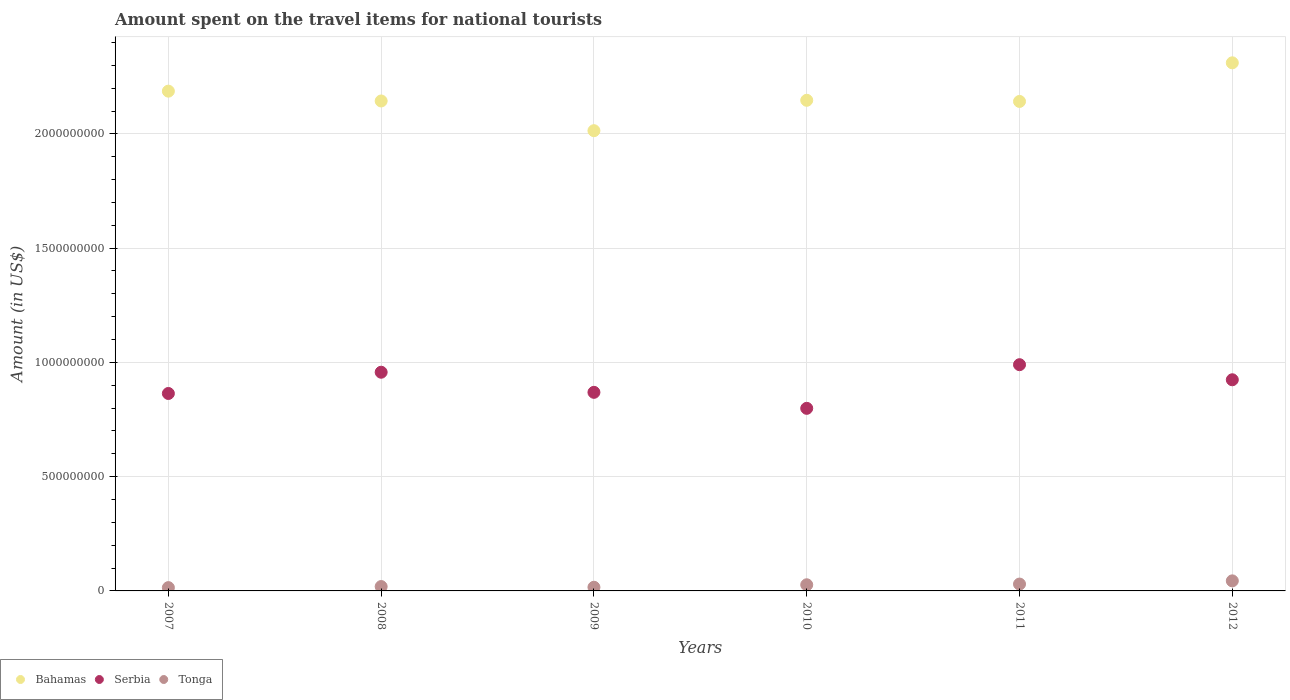How many different coloured dotlines are there?
Give a very brief answer. 3. What is the amount spent on the travel items for national tourists in Serbia in 2010?
Provide a short and direct response. 7.99e+08. Across all years, what is the maximum amount spent on the travel items for national tourists in Tonga?
Give a very brief answer. 4.40e+07. Across all years, what is the minimum amount spent on the travel items for national tourists in Tonga?
Make the answer very short. 1.44e+07. In which year was the amount spent on the travel items for national tourists in Serbia maximum?
Keep it short and to the point. 2011. What is the total amount spent on the travel items for national tourists in Tonga in the graph?
Make the answer very short. 1.50e+08. What is the difference between the amount spent on the travel items for national tourists in Serbia in 2009 and that in 2012?
Ensure brevity in your answer.  -5.50e+07. What is the difference between the amount spent on the travel items for national tourists in Serbia in 2008 and the amount spent on the travel items for national tourists in Bahamas in 2007?
Give a very brief answer. -1.23e+09. What is the average amount spent on the travel items for national tourists in Serbia per year?
Your answer should be very brief. 9.00e+08. In the year 2010, what is the difference between the amount spent on the travel items for national tourists in Serbia and amount spent on the travel items for national tourists in Tonga?
Provide a short and direct response. 7.72e+08. What is the ratio of the amount spent on the travel items for national tourists in Serbia in 2007 to that in 2012?
Your response must be concise. 0.94. Is the difference between the amount spent on the travel items for national tourists in Serbia in 2008 and 2010 greater than the difference between the amount spent on the travel items for national tourists in Tonga in 2008 and 2010?
Give a very brief answer. Yes. What is the difference between the highest and the second highest amount spent on the travel items for national tourists in Serbia?
Your answer should be very brief. 3.30e+07. What is the difference between the highest and the lowest amount spent on the travel items for national tourists in Bahamas?
Keep it short and to the point. 2.97e+08. In how many years, is the amount spent on the travel items for national tourists in Serbia greater than the average amount spent on the travel items for national tourists in Serbia taken over all years?
Provide a short and direct response. 3. Is it the case that in every year, the sum of the amount spent on the travel items for national tourists in Tonga and amount spent on the travel items for national tourists in Serbia  is greater than the amount spent on the travel items for national tourists in Bahamas?
Your answer should be very brief. No. Does the amount spent on the travel items for national tourists in Serbia monotonically increase over the years?
Give a very brief answer. No. How many dotlines are there?
Offer a very short reply. 3. How many years are there in the graph?
Keep it short and to the point. 6. Does the graph contain any zero values?
Ensure brevity in your answer.  No. How are the legend labels stacked?
Ensure brevity in your answer.  Horizontal. What is the title of the graph?
Keep it short and to the point. Amount spent on the travel items for national tourists. Does "Georgia" appear as one of the legend labels in the graph?
Your answer should be very brief. No. What is the Amount (in US$) in Bahamas in 2007?
Ensure brevity in your answer.  2.19e+09. What is the Amount (in US$) in Serbia in 2007?
Your answer should be compact. 8.64e+08. What is the Amount (in US$) of Tonga in 2007?
Keep it short and to the point. 1.44e+07. What is the Amount (in US$) of Bahamas in 2008?
Make the answer very short. 2.14e+09. What is the Amount (in US$) of Serbia in 2008?
Give a very brief answer. 9.57e+08. What is the Amount (in US$) in Tonga in 2008?
Provide a short and direct response. 1.91e+07. What is the Amount (in US$) in Bahamas in 2009?
Offer a terse response. 2.01e+09. What is the Amount (in US$) of Serbia in 2009?
Your answer should be very brief. 8.69e+08. What is the Amount (in US$) of Tonga in 2009?
Your answer should be very brief. 1.60e+07. What is the Amount (in US$) of Bahamas in 2010?
Keep it short and to the point. 2.15e+09. What is the Amount (in US$) in Serbia in 2010?
Keep it short and to the point. 7.99e+08. What is the Amount (in US$) in Tonga in 2010?
Your response must be concise. 2.69e+07. What is the Amount (in US$) in Bahamas in 2011?
Provide a succinct answer. 2.14e+09. What is the Amount (in US$) in Serbia in 2011?
Give a very brief answer. 9.90e+08. What is the Amount (in US$) of Tonga in 2011?
Make the answer very short. 3.00e+07. What is the Amount (in US$) of Bahamas in 2012?
Give a very brief answer. 2.31e+09. What is the Amount (in US$) in Serbia in 2012?
Make the answer very short. 9.24e+08. What is the Amount (in US$) in Tonga in 2012?
Provide a short and direct response. 4.40e+07. Across all years, what is the maximum Amount (in US$) of Bahamas?
Make the answer very short. 2.31e+09. Across all years, what is the maximum Amount (in US$) of Serbia?
Ensure brevity in your answer.  9.90e+08. Across all years, what is the maximum Amount (in US$) in Tonga?
Make the answer very short. 4.40e+07. Across all years, what is the minimum Amount (in US$) of Bahamas?
Your answer should be very brief. 2.01e+09. Across all years, what is the minimum Amount (in US$) of Serbia?
Provide a succinct answer. 7.99e+08. Across all years, what is the minimum Amount (in US$) of Tonga?
Your answer should be compact. 1.44e+07. What is the total Amount (in US$) in Bahamas in the graph?
Your answer should be very brief. 1.29e+1. What is the total Amount (in US$) in Serbia in the graph?
Ensure brevity in your answer.  5.40e+09. What is the total Amount (in US$) in Tonga in the graph?
Keep it short and to the point. 1.50e+08. What is the difference between the Amount (in US$) in Bahamas in 2007 and that in 2008?
Offer a very short reply. 4.30e+07. What is the difference between the Amount (in US$) of Serbia in 2007 and that in 2008?
Offer a very short reply. -9.30e+07. What is the difference between the Amount (in US$) of Tonga in 2007 and that in 2008?
Your response must be concise. -4.70e+06. What is the difference between the Amount (in US$) in Bahamas in 2007 and that in 2009?
Ensure brevity in your answer.  1.73e+08. What is the difference between the Amount (in US$) in Serbia in 2007 and that in 2009?
Offer a very short reply. -5.00e+06. What is the difference between the Amount (in US$) of Tonga in 2007 and that in 2009?
Ensure brevity in your answer.  -1.60e+06. What is the difference between the Amount (in US$) of Bahamas in 2007 and that in 2010?
Offer a terse response. 4.00e+07. What is the difference between the Amount (in US$) of Serbia in 2007 and that in 2010?
Offer a very short reply. 6.50e+07. What is the difference between the Amount (in US$) in Tonga in 2007 and that in 2010?
Your response must be concise. -1.25e+07. What is the difference between the Amount (in US$) in Bahamas in 2007 and that in 2011?
Make the answer very short. 4.50e+07. What is the difference between the Amount (in US$) of Serbia in 2007 and that in 2011?
Offer a very short reply. -1.26e+08. What is the difference between the Amount (in US$) in Tonga in 2007 and that in 2011?
Keep it short and to the point. -1.56e+07. What is the difference between the Amount (in US$) in Bahamas in 2007 and that in 2012?
Your response must be concise. -1.24e+08. What is the difference between the Amount (in US$) of Serbia in 2007 and that in 2012?
Ensure brevity in your answer.  -6.00e+07. What is the difference between the Amount (in US$) of Tonga in 2007 and that in 2012?
Keep it short and to the point. -2.96e+07. What is the difference between the Amount (in US$) in Bahamas in 2008 and that in 2009?
Your answer should be very brief. 1.30e+08. What is the difference between the Amount (in US$) in Serbia in 2008 and that in 2009?
Provide a short and direct response. 8.80e+07. What is the difference between the Amount (in US$) in Tonga in 2008 and that in 2009?
Provide a succinct answer. 3.10e+06. What is the difference between the Amount (in US$) of Serbia in 2008 and that in 2010?
Provide a succinct answer. 1.58e+08. What is the difference between the Amount (in US$) in Tonga in 2008 and that in 2010?
Your answer should be compact. -7.80e+06. What is the difference between the Amount (in US$) in Bahamas in 2008 and that in 2011?
Provide a succinct answer. 2.00e+06. What is the difference between the Amount (in US$) in Serbia in 2008 and that in 2011?
Provide a succinct answer. -3.30e+07. What is the difference between the Amount (in US$) in Tonga in 2008 and that in 2011?
Your response must be concise. -1.09e+07. What is the difference between the Amount (in US$) in Bahamas in 2008 and that in 2012?
Offer a very short reply. -1.67e+08. What is the difference between the Amount (in US$) in Serbia in 2008 and that in 2012?
Provide a short and direct response. 3.30e+07. What is the difference between the Amount (in US$) in Tonga in 2008 and that in 2012?
Provide a succinct answer. -2.49e+07. What is the difference between the Amount (in US$) of Bahamas in 2009 and that in 2010?
Provide a short and direct response. -1.33e+08. What is the difference between the Amount (in US$) in Serbia in 2009 and that in 2010?
Provide a short and direct response. 7.00e+07. What is the difference between the Amount (in US$) of Tonga in 2009 and that in 2010?
Your response must be concise. -1.09e+07. What is the difference between the Amount (in US$) in Bahamas in 2009 and that in 2011?
Your response must be concise. -1.28e+08. What is the difference between the Amount (in US$) of Serbia in 2009 and that in 2011?
Your response must be concise. -1.21e+08. What is the difference between the Amount (in US$) of Tonga in 2009 and that in 2011?
Give a very brief answer. -1.40e+07. What is the difference between the Amount (in US$) of Bahamas in 2009 and that in 2012?
Offer a terse response. -2.97e+08. What is the difference between the Amount (in US$) in Serbia in 2009 and that in 2012?
Ensure brevity in your answer.  -5.50e+07. What is the difference between the Amount (in US$) of Tonga in 2009 and that in 2012?
Give a very brief answer. -2.80e+07. What is the difference between the Amount (in US$) in Bahamas in 2010 and that in 2011?
Provide a short and direct response. 5.00e+06. What is the difference between the Amount (in US$) in Serbia in 2010 and that in 2011?
Provide a short and direct response. -1.91e+08. What is the difference between the Amount (in US$) in Tonga in 2010 and that in 2011?
Ensure brevity in your answer.  -3.10e+06. What is the difference between the Amount (in US$) in Bahamas in 2010 and that in 2012?
Provide a short and direct response. -1.64e+08. What is the difference between the Amount (in US$) in Serbia in 2010 and that in 2012?
Your answer should be very brief. -1.25e+08. What is the difference between the Amount (in US$) of Tonga in 2010 and that in 2012?
Offer a terse response. -1.71e+07. What is the difference between the Amount (in US$) in Bahamas in 2011 and that in 2012?
Provide a short and direct response. -1.69e+08. What is the difference between the Amount (in US$) in Serbia in 2011 and that in 2012?
Provide a succinct answer. 6.60e+07. What is the difference between the Amount (in US$) of Tonga in 2011 and that in 2012?
Provide a short and direct response. -1.40e+07. What is the difference between the Amount (in US$) of Bahamas in 2007 and the Amount (in US$) of Serbia in 2008?
Give a very brief answer. 1.23e+09. What is the difference between the Amount (in US$) in Bahamas in 2007 and the Amount (in US$) in Tonga in 2008?
Ensure brevity in your answer.  2.17e+09. What is the difference between the Amount (in US$) in Serbia in 2007 and the Amount (in US$) in Tonga in 2008?
Ensure brevity in your answer.  8.45e+08. What is the difference between the Amount (in US$) in Bahamas in 2007 and the Amount (in US$) in Serbia in 2009?
Your answer should be compact. 1.32e+09. What is the difference between the Amount (in US$) in Bahamas in 2007 and the Amount (in US$) in Tonga in 2009?
Keep it short and to the point. 2.17e+09. What is the difference between the Amount (in US$) of Serbia in 2007 and the Amount (in US$) of Tonga in 2009?
Ensure brevity in your answer.  8.48e+08. What is the difference between the Amount (in US$) of Bahamas in 2007 and the Amount (in US$) of Serbia in 2010?
Your response must be concise. 1.39e+09. What is the difference between the Amount (in US$) in Bahamas in 2007 and the Amount (in US$) in Tonga in 2010?
Keep it short and to the point. 2.16e+09. What is the difference between the Amount (in US$) of Serbia in 2007 and the Amount (in US$) of Tonga in 2010?
Your answer should be very brief. 8.37e+08. What is the difference between the Amount (in US$) of Bahamas in 2007 and the Amount (in US$) of Serbia in 2011?
Keep it short and to the point. 1.20e+09. What is the difference between the Amount (in US$) in Bahamas in 2007 and the Amount (in US$) in Tonga in 2011?
Your response must be concise. 2.16e+09. What is the difference between the Amount (in US$) in Serbia in 2007 and the Amount (in US$) in Tonga in 2011?
Your answer should be compact. 8.34e+08. What is the difference between the Amount (in US$) of Bahamas in 2007 and the Amount (in US$) of Serbia in 2012?
Make the answer very short. 1.26e+09. What is the difference between the Amount (in US$) in Bahamas in 2007 and the Amount (in US$) in Tonga in 2012?
Your answer should be very brief. 2.14e+09. What is the difference between the Amount (in US$) of Serbia in 2007 and the Amount (in US$) of Tonga in 2012?
Make the answer very short. 8.20e+08. What is the difference between the Amount (in US$) of Bahamas in 2008 and the Amount (in US$) of Serbia in 2009?
Give a very brief answer. 1.28e+09. What is the difference between the Amount (in US$) in Bahamas in 2008 and the Amount (in US$) in Tonga in 2009?
Ensure brevity in your answer.  2.13e+09. What is the difference between the Amount (in US$) of Serbia in 2008 and the Amount (in US$) of Tonga in 2009?
Keep it short and to the point. 9.41e+08. What is the difference between the Amount (in US$) in Bahamas in 2008 and the Amount (in US$) in Serbia in 2010?
Your response must be concise. 1.34e+09. What is the difference between the Amount (in US$) in Bahamas in 2008 and the Amount (in US$) in Tonga in 2010?
Provide a succinct answer. 2.12e+09. What is the difference between the Amount (in US$) of Serbia in 2008 and the Amount (in US$) of Tonga in 2010?
Offer a very short reply. 9.30e+08. What is the difference between the Amount (in US$) in Bahamas in 2008 and the Amount (in US$) in Serbia in 2011?
Provide a short and direct response. 1.15e+09. What is the difference between the Amount (in US$) in Bahamas in 2008 and the Amount (in US$) in Tonga in 2011?
Ensure brevity in your answer.  2.11e+09. What is the difference between the Amount (in US$) in Serbia in 2008 and the Amount (in US$) in Tonga in 2011?
Make the answer very short. 9.27e+08. What is the difference between the Amount (in US$) of Bahamas in 2008 and the Amount (in US$) of Serbia in 2012?
Make the answer very short. 1.22e+09. What is the difference between the Amount (in US$) of Bahamas in 2008 and the Amount (in US$) of Tonga in 2012?
Give a very brief answer. 2.10e+09. What is the difference between the Amount (in US$) in Serbia in 2008 and the Amount (in US$) in Tonga in 2012?
Your answer should be compact. 9.13e+08. What is the difference between the Amount (in US$) in Bahamas in 2009 and the Amount (in US$) in Serbia in 2010?
Make the answer very short. 1.22e+09. What is the difference between the Amount (in US$) in Bahamas in 2009 and the Amount (in US$) in Tonga in 2010?
Provide a short and direct response. 1.99e+09. What is the difference between the Amount (in US$) in Serbia in 2009 and the Amount (in US$) in Tonga in 2010?
Offer a terse response. 8.42e+08. What is the difference between the Amount (in US$) in Bahamas in 2009 and the Amount (in US$) in Serbia in 2011?
Your answer should be very brief. 1.02e+09. What is the difference between the Amount (in US$) in Bahamas in 2009 and the Amount (in US$) in Tonga in 2011?
Your response must be concise. 1.98e+09. What is the difference between the Amount (in US$) in Serbia in 2009 and the Amount (in US$) in Tonga in 2011?
Offer a terse response. 8.39e+08. What is the difference between the Amount (in US$) in Bahamas in 2009 and the Amount (in US$) in Serbia in 2012?
Offer a terse response. 1.09e+09. What is the difference between the Amount (in US$) in Bahamas in 2009 and the Amount (in US$) in Tonga in 2012?
Your answer should be compact. 1.97e+09. What is the difference between the Amount (in US$) in Serbia in 2009 and the Amount (in US$) in Tonga in 2012?
Your response must be concise. 8.25e+08. What is the difference between the Amount (in US$) of Bahamas in 2010 and the Amount (in US$) of Serbia in 2011?
Your answer should be compact. 1.16e+09. What is the difference between the Amount (in US$) in Bahamas in 2010 and the Amount (in US$) in Tonga in 2011?
Your response must be concise. 2.12e+09. What is the difference between the Amount (in US$) in Serbia in 2010 and the Amount (in US$) in Tonga in 2011?
Offer a very short reply. 7.69e+08. What is the difference between the Amount (in US$) of Bahamas in 2010 and the Amount (in US$) of Serbia in 2012?
Your response must be concise. 1.22e+09. What is the difference between the Amount (in US$) in Bahamas in 2010 and the Amount (in US$) in Tonga in 2012?
Offer a very short reply. 2.10e+09. What is the difference between the Amount (in US$) of Serbia in 2010 and the Amount (in US$) of Tonga in 2012?
Give a very brief answer. 7.55e+08. What is the difference between the Amount (in US$) in Bahamas in 2011 and the Amount (in US$) in Serbia in 2012?
Your response must be concise. 1.22e+09. What is the difference between the Amount (in US$) in Bahamas in 2011 and the Amount (in US$) in Tonga in 2012?
Provide a short and direct response. 2.10e+09. What is the difference between the Amount (in US$) in Serbia in 2011 and the Amount (in US$) in Tonga in 2012?
Offer a very short reply. 9.46e+08. What is the average Amount (in US$) in Bahamas per year?
Give a very brief answer. 2.16e+09. What is the average Amount (in US$) of Serbia per year?
Provide a succinct answer. 9.00e+08. What is the average Amount (in US$) of Tonga per year?
Offer a terse response. 2.51e+07. In the year 2007, what is the difference between the Amount (in US$) in Bahamas and Amount (in US$) in Serbia?
Your answer should be very brief. 1.32e+09. In the year 2007, what is the difference between the Amount (in US$) in Bahamas and Amount (in US$) in Tonga?
Your answer should be compact. 2.17e+09. In the year 2007, what is the difference between the Amount (in US$) of Serbia and Amount (in US$) of Tonga?
Keep it short and to the point. 8.50e+08. In the year 2008, what is the difference between the Amount (in US$) in Bahamas and Amount (in US$) in Serbia?
Provide a succinct answer. 1.19e+09. In the year 2008, what is the difference between the Amount (in US$) of Bahamas and Amount (in US$) of Tonga?
Keep it short and to the point. 2.12e+09. In the year 2008, what is the difference between the Amount (in US$) in Serbia and Amount (in US$) in Tonga?
Your answer should be compact. 9.38e+08. In the year 2009, what is the difference between the Amount (in US$) in Bahamas and Amount (in US$) in Serbia?
Keep it short and to the point. 1.14e+09. In the year 2009, what is the difference between the Amount (in US$) of Bahamas and Amount (in US$) of Tonga?
Make the answer very short. 2.00e+09. In the year 2009, what is the difference between the Amount (in US$) in Serbia and Amount (in US$) in Tonga?
Your answer should be very brief. 8.53e+08. In the year 2010, what is the difference between the Amount (in US$) in Bahamas and Amount (in US$) in Serbia?
Your answer should be very brief. 1.35e+09. In the year 2010, what is the difference between the Amount (in US$) in Bahamas and Amount (in US$) in Tonga?
Keep it short and to the point. 2.12e+09. In the year 2010, what is the difference between the Amount (in US$) in Serbia and Amount (in US$) in Tonga?
Keep it short and to the point. 7.72e+08. In the year 2011, what is the difference between the Amount (in US$) in Bahamas and Amount (in US$) in Serbia?
Make the answer very short. 1.15e+09. In the year 2011, what is the difference between the Amount (in US$) in Bahamas and Amount (in US$) in Tonga?
Your answer should be very brief. 2.11e+09. In the year 2011, what is the difference between the Amount (in US$) of Serbia and Amount (in US$) of Tonga?
Ensure brevity in your answer.  9.60e+08. In the year 2012, what is the difference between the Amount (in US$) in Bahamas and Amount (in US$) in Serbia?
Your answer should be very brief. 1.39e+09. In the year 2012, what is the difference between the Amount (in US$) of Bahamas and Amount (in US$) of Tonga?
Ensure brevity in your answer.  2.27e+09. In the year 2012, what is the difference between the Amount (in US$) of Serbia and Amount (in US$) of Tonga?
Make the answer very short. 8.80e+08. What is the ratio of the Amount (in US$) in Bahamas in 2007 to that in 2008?
Ensure brevity in your answer.  1.02. What is the ratio of the Amount (in US$) in Serbia in 2007 to that in 2008?
Offer a terse response. 0.9. What is the ratio of the Amount (in US$) of Tonga in 2007 to that in 2008?
Offer a terse response. 0.75. What is the ratio of the Amount (in US$) in Bahamas in 2007 to that in 2009?
Offer a very short reply. 1.09. What is the ratio of the Amount (in US$) in Bahamas in 2007 to that in 2010?
Your answer should be very brief. 1.02. What is the ratio of the Amount (in US$) in Serbia in 2007 to that in 2010?
Provide a succinct answer. 1.08. What is the ratio of the Amount (in US$) of Tonga in 2007 to that in 2010?
Offer a terse response. 0.54. What is the ratio of the Amount (in US$) of Serbia in 2007 to that in 2011?
Provide a succinct answer. 0.87. What is the ratio of the Amount (in US$) in Tonga in 2007 to that in 2011?
Offer a very short reply. 0.48. What is the ratio of the Amount (in US$) in Bahamas in 2007 to that in 2012?
Provide a short and direct response. 0.95. What is the ratio of the Amount (in US$) of Serbia in 2007 to that in 2012?
Ensure brevity in your answer.  0.94. What is the ratio of the Amount (in US$) in Tonga in 2007 to that in 2012?
Your answer should be compact. 0.33. What is the ratio of the Amount (in US$) in Bahamas in 2008 to that in 2009?
Make the answer very short. 1.06. What is the ratio of the Amount (in US$) in Serbia in 2008 to that in 2009?
Provide a succinct answer. 1.1. What is the ratio of the Amount (in US$) of Tonga in 2008 to that in 2009?
Keep it short and to the point. 1.19. What is the ratio of the Amount (in US$) in Serbia in 2008 to that in 2010?
Your response must be concise. 1.2. What is the ratio of the Amount (in US$) of Tonga in 2008 to that in 2010?
Your answer should be very brief. 0.71. What is the ratio of the Amount (in US$) in Bahamas in 2008 to that in 2011?
Make the answer very short. 1. What is the ratio of the Amount (in US$) in Serbia in 2008 to that in 2011?
Your response must be concise. 0.97. What is the ratio of the Amount (in US$) in Tonga in 2008 to that in 2011?
Provide a short and direct response. 0.64. What is the ratio of the Amount (in US$) of Bahamas in 2008 to that in 2012?
Offer a terse response. 0.93. What is the ratio of the Amount (in US$) of Serbia in 2008 to that in 2012?
Offer a terse response. 1.04. What is the ratio of the Amount (in US$) in Tonga in 2008 to that in 2012?
Your response must be concise. 0.43. What is the ratio of the Amount (in US$) in Bahamas in 2009 to that in 2010?
Your answer should be compact. 0.94. What is the ratio of the Amount (in US$) in Serbia in 2009 to that in 2010?
Make the answer very short. 1.09. What is the ratio of the Amount (in US$) of Tonga in 2009 to that in 2010?
Provide a short and direct response. 0.59. What is the ratio of the Amount (in US$) in Bahamas in 2009 to that in 2011?
Your answer should be compact. 0.94. What is the ratio of the Amount (in US$) in Serbia in 2009 to that in 2011?
Offer a terse response. 0.88. What is the ratio of the Amount (in US$) of Tonga in 2009 to that in 2011?
Offer a terse response. 0.53. What is the ratio of the Amount (in US$) of Bahamas in 2009 to that in 2012?
Ensure brevity in your answer.  0.87. What is the ratio of the Amount (in US$) in Serbia in 2009 to that in 2012?
Your response must be concise. 0.94. What is the ratio of the Amount (in US$) in Tonga in 2009 to that in 2012?
Provide a succinct answer. 0.36. What is the ratio of the Amount (in US$) in Serbia in 2010 to that in 2011?
Make the answer very short. 0.81. What is the ratio of the Amount (in US$) of Tonga in 2010 to that in 2011?
Your answer should be compact. 0.9. What is the ratio of the Amount (in US$) of Bahamas in 2010 to that in 2012?
Keep it short and to the point. 0.93. What is the ratio of the Amount (in US$) in Serbia in 2010 to that in 2012?
Keep it short and to the point. 0.86. What is the ratio of the Amount (in US$) in Tonga in 2010 to that in 2012?
Your response must be concise. 0.61. What is the ratio of the Amount (in US$) of Bahamas in 2011 to that in 2012?
Provide a succinct answer. 0.93. What is the ratio of the Amount (in US$) in Serbia in 2011 to that in 2012?
Your answer should be compact. 1.07. What is the ratio of the Amount (in US$) of Tonga in 2011 to that in 2012?
Make the answer very short. 0.68. What is the difference between the highest and the second highest Amount (in US$) of Bahamas?
Offer a very short reply. 1.24e+08. What is the difference between the highest and the second highest Amount (in US$) of Serbia?
Keep it short and to the point. 3.30e+07. What is the difference between the highest and the second highest Amount (in US$) in Tonga?
Offer a very short reply. 1.40e+07. What is the difference between the highest and the lowest Amount (in US$) of Bahamas?
Offer a very short reply. 2.97e+08. What is the difference between the highest and the lowest Amount (in US$) in Serbia?
Your response must be concise. 1.91e+08. What is the difference between the highest and the lowest Amount (in US$) in Tonga?
Ensure brevity in your answer.  2.96e+07. 